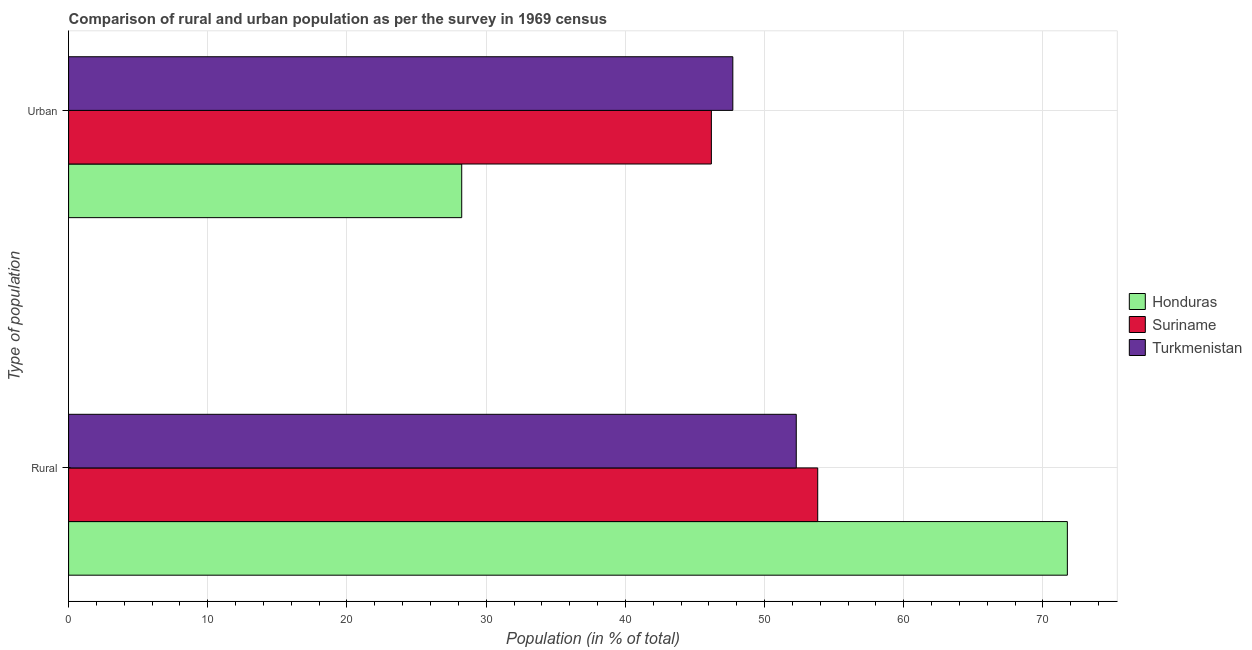How many different coloured bars are there?
Offer a very short reply. 3. What is the label of the 1st group of bars from the top?
Keep it short and to the point. Urban. What is the urban population in Honduras?
Give a very brief answer. 28.24. Across all countries, what is the maximum urban population?
Make the answer very short. 47.72. Across all countries, what is the minimum urban population?
Provide a short and direct response. 28.24. In which country was the urban population maximum?
Provide a short and direct response. Turkmenistan. In which country was the rural population minimum?
Provide a short and direct response. Turkmenistan. What is the total rural population in the graph?
Keep it short and to the point. 177.85. What is the difference between the urban population in Suriname and that in Honduras?
Ensure brevity in your answer.  17.94. What is the difference between the urban population in Honduras and the rural population in Turkmenistan?
Provide a short and direct response. -24.04. What is the average urban population per country?
Ensure brevity in your answer.  40.72. What is the difference between the rural population and urban population in Suriname?
Provide a short and direct response. 7.64. What is the ratio of the urban population in Turkmenistan to that in Suriname?
Give a very brief answer. 1.03. What does the 3rd bar from the top in Rural represents?
Offer a very short reply. Honduras. What does the 3rd bar from the bottom in Urban represents?
Your response must be concise. Turkmenistan. Does the graph contain any zero values?
Make the answer very short. No. Does the graph contain grids?
Offer a very short reply. Yes. How many legend labels are there?
Your answer should be compact. 3. How are the legend labels stacked?
Ensure brevity in your answer.  Vertical. What is the title of the graph?
Offer a very short reply. Comparison of rural and urban population as per the survey in 1969 census. Does "Luxembourg" appear as one of the legend labels in the graph?
Your answer should be very brief. No. What is the label or title of the X-axis?
Your response must be concise. Population (in % of total). What is the label or title of the Y-axis?
Make the answer very short. Type of population. What is the Population (in % of total) in Honduras in Rural?
Your response must be concise. 71.76. What is the Population (in % of total) in Suriname in Rural?
Provide a short and direct response. 53.82. What is the Population (in % of total) of Turkmenistan in Rural?
Keep it short and to the point. 52.28. What is the Population (in % of total) of Honduras in Urban?
Offer a very short reply. 28.24. What is the Population (in % of total) of Suriname in Urban?
Provide a succinct answer. 46.18. What is the Population (in % of total) in Turkmenistan in Urban?
Provide a succinct answer. 47.72. Across all Type of population, what is the maximum Population (in % of total) in Honduras?
Ensure brevity in your answer.  71.76. Across all Type of population, what is the maximum Population (in % of total) in Suriname?
Ensure brevity in your answer.  53.82. Across all Type of population, what is the maximum Population (in % of total) in Turkmenistan?
Your response must be concise. 52.28. Across all Type of population, what is the minimum Population (in % of total) of Honduras?
Ensure brevity in your answer.  28.24. Across all Type of population, what is the minimum Population (in % of total) in Suriname?
Give a very brief answer. 46.18. Across all Type of population, what is the minimum Population (in % of total) of Turkmenistan?
Provide a short and direct response. 47.72. What is the total Population (in % of total) in Honduras in the graph?
Offer a very short reply. 100. What is the total Population (in % of total) in Turkmenistan in the graph?
Your answer should be compact. 100. What is the difference between the Population (in % of total) of Honduras in Rural and that in Urban?
Offer a very short reply. 43.51. What is the difference between the Population (in % of total) of Suriname in Rural and that in Urban?
Your answer should be very brief. 7.64. What is the difference between the Population (in % of total) of Turkmenistan in Rural and that in Urban?
Offer a terse response. 4.56. What is the difference between the Population (in % of total) of Honduras in Rural and the Population (in % of total) of Suriname in Urban?
Offer a terse response. 25.58. What is the difference between the Population (in % of total) in Honduras in Rural and the Population (in % of total) in Turkmenistan in Urban?
Give a very brief answer. 24.04. What is the difference between the Population (in % of total) in Suriname in Rural and the Population (in % of total) in Turkmenistan in Urban?
Provide a short and direct response. 6.1. What is the average Population (in % of total) of Honduras per Type of population?
Make the answer very short. 50. What is the average Population (in % of total) in Turkmenistan per Type of population?
Offer a terse response. 50. What is the difference between the Population (in % of total) of Honduras and Population (in % of total) of Suriname in Rural?
Your answer should be compact. 17.94. What is the difference between the Population (in % of total) in Honduras and Population (in % of total) in Turkmenistan in Rural?
Offer a very short reply. 19.48. What is the difference between the Population (in % of total) in Suriname and Population (in % of total) in Turkmenistan in Rural?
Provide a succinct answer. 1.54. What is the difference between the Population (in % of total) in Honduras and Population (in % of total) in Suriname in Urban?
Ensure brevity in your answer.  -17.94. What is the difference between the Population (in % of total) in Honduras and Population (in % of total) in Turkmenistan in Urban?
Keep it short and to the point. -19.48. What is the difference between the Population (in % of total) of Suriname and Population (in % of total) of Turkmenistan in Urban?
Provide a short and direct response. -1.54. What is the ratio of the Population (in % of total) of Honduras in Rural to that in Urban?
Keep it short and to the point. 2.54. What is the ratio of the Population (in % of total) of Suriname in Rural to that in Urban?
Offer a very short reply. 1.17. What is the ratio of the Population (in % of total) in Turkmenistan in Rural to that in Urban?
Offer a very short reply. 1.1. What is the difference between the highest and the second highest Population (in % of total) of Honduras?
Provide a succinct answer. 43.51. What is the difference between the highest and the second highest Population (in % of total) in Suriname?
Offer a very short reply. 7.64. What is the difference between the highest and the second highest Population (in % of total) of Turkmenistan?
Give a very brief answer. 4.56. What is the difference between the highest and the lowest Population (in % of total) in Honduras?
Offer a terse response. 43.51. What is the difference between the highest and the lowest Population (in % of total) in Suriname?
Give a very brief answer. 7.64. What is the difference between the highest and the lowest Population (in % of total) in Turkmenistan?
Your answer should be very brief. 4.56. 